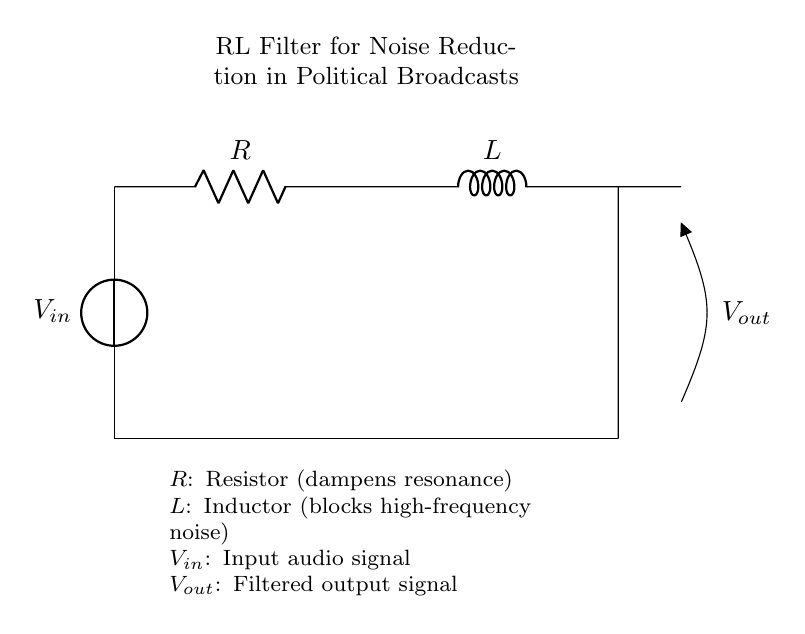What is the input signal represented in the circuit? The input signal is denoted as \( V_{in} \), which is the voltage source applied at the top of the circuit.
Answer: \( V_{in} \) What component is used to dampen resonance? In the circuit, the resistor \( R \) provides damping, which helps to reduce overshooting and resonance effects that can occur.
Answer: \( R \) What does the inductor do in this circuit? The inductor \( L \) acts as a filter that blocks high-frequency noise from being transferred to the output, allowing only lower frequencies to pass through.
Answer: Blocks high-frequency noise What is the output signal called in this diagram? The output signal is represented by \( V_{out} \), which is the voltage after filtering the input signal through the resistor and inductor.
Answer: \( V_{out} \) What would happen if we increase the resistance \( R \)? Increasing the resistance \( R \) would result in more damping, which would reduce peak resonance but may also lower the output signal level, particularly for lower frequencies.
Answer: More damping What type of filter is represented in this circuit? The circuit is classified as a low-pass filter, as it allows lower frequencies to pass while attenuating higher frequencies.
Answer: Low-pass filter How does the voltage drop across the inductor \( L \) change with frequency? The voltage drop across the inductor increases with frequency because the inductor's reactance also increases, thereby blocking more of the AC signal.
Answer: Increases with frequency 